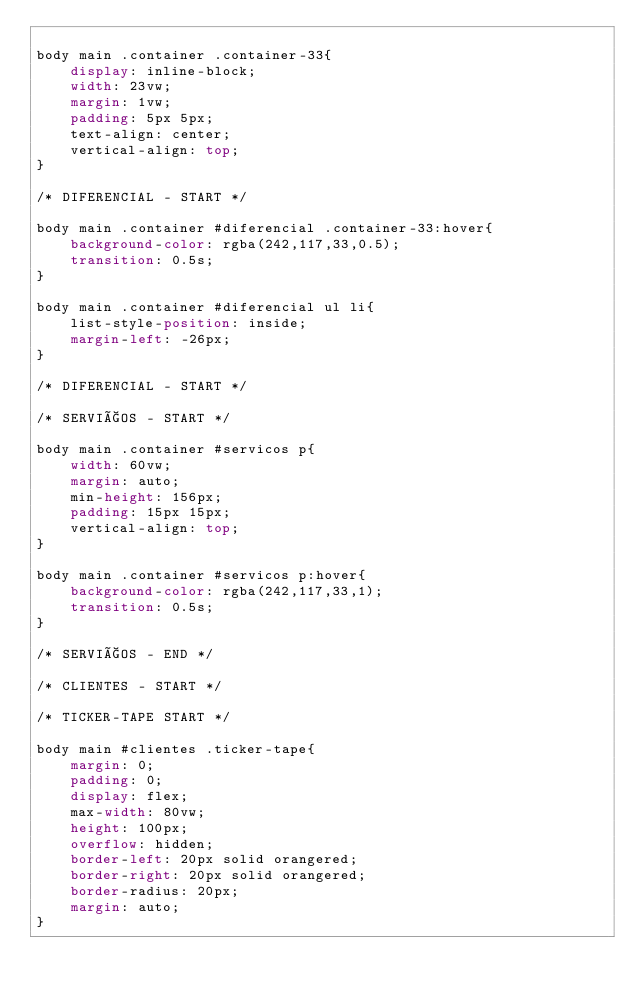Convert code to text. <code><loc_0><loc_0><loc_500><loc_500><_CSS_>
body main .container .container-33{
    display: inline-block;
    width: 23vw;
    margin: 1vw;
    padding: 5px 5px;
    text-align: center;
    vertical-align: top;
}

/* DIFERENCIAL - START */

body main .container #diferencial .container-33:hover{
    background-color: rgba(242,117,33,0.5);
    transition: 0.5s;
}

body main .container #diferencial ul li{
    list-style-position: inside;
    margin-left: -26px;
}

/* DIFERENCIAL - START */

/* SERVIÇOS - START */

body main .container #servicos p{
    width: 60vw;
    margin: auto;
    min-height: 156px;
    padding: 15px 15px;
    vertical-align: top;
}

body main .container #servicos p:hover{
    background-color: rgba(242,117,33,1);
    transition: 0.5s;
}

/* SERVIÇOS - END */

/* CLIENTES - START */

/* TICKER-TAPE START */

body main #clientes .ticker-tape{
    margin: 0;
    padding: 0;
    display: flex;
    max-width: 80vw;
    height: 100px;
    overflow: hidden;
    border-left: 20px solid orangered;
    border-right: 20px solid orangered;
    border-radius: 20px;
    margin: auto;
}
</code> 